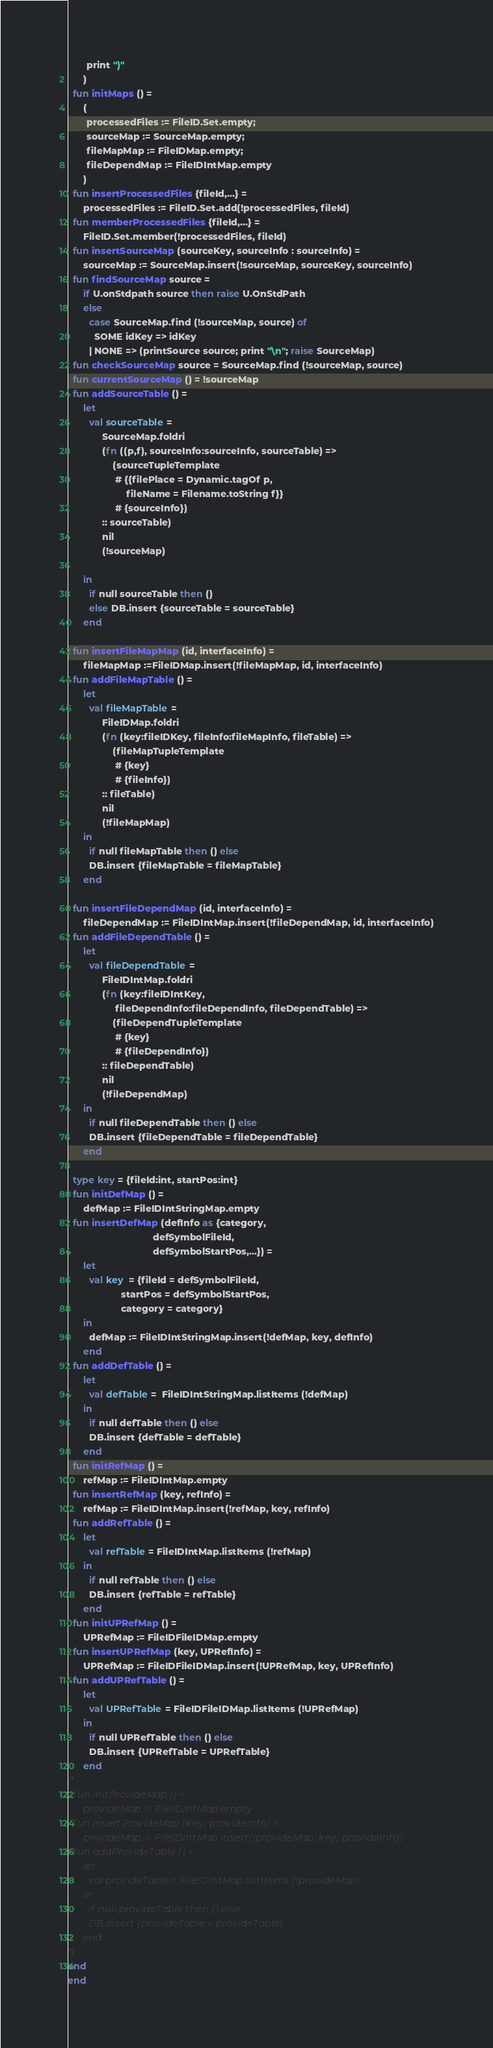Convert code to text. <code><loc_0><loc_0><loc_500><loc_500><_SML_>       print ")"
      )
  fun initMaps () = 
      (
       processedFiles := FileID.Set.empty;
       sourceMap := SourceMap.empty;
       fileMapMap := FileIDMap.empty;
       fileDependMap := FileIDIntMap.empty
      )
  fun insertProcessedFiles {fileId,...} = 
      processedFiles := FileID.Set.add(!processedFiles, fileId)
  fun memberProcessedFiles {fileId,...} = 
      FileID.Set.member(!processedFiles, fileId)
  fun insertSourceMap (sourceKey, sourceInfo : sourceInfo) =
      sourceMap := SourceMap.insert(!sourceMap, sourceKey, sourceInfo)
  fun findSourceMap source = 
      if U.onStdpath source then raise U.OnStdPath
      else
        case SourceMap.find (!sourceMap, source) of 
          SOME idKey => idKey
        | NONE => (printSource source; print "\n"; raise SourceMap)
  fun checkSourceMap source = SourceMap.find (!sourceMap, source)
  fun currentSourceMap () = !sourceMap
  fun addSourceTable () = 
      let
        val sourceTable = 
             SourceMap.foldri
             (fn ((p,f), sourceInfo:sourceInfo, sourceTable) =>
                 (sourceTupleTemplate
                  # {{filePlace = Dynamic.tagOf p, 
                      fileName = Filename.toString f}}
                  # {sourceInfo})
             :: sourceTable)
             nil
             (!sourceMap)

      in
        if null sourceTable then ()
        else DB.insert {sourceTable = sourceTable}
      end

  fun insertFileMapMap (id, interfaceInfo) = 
      fileMapMap :=FileIDMap.insert(!fileMapMap, id, interfaceInfo)
  fun addFileMapTable () =
      let
        val fileMapTable = 
             FileIDMap.foldri
             (fn (key:fileIDKey, fileInfo:fileMapInfo, fileTable) =>
                 (fileMapTupleTemplate
                  # {key}
                  # {fileInfo})
             :: fileTable)
             nil
             (!fileMapMap)
      in
        if null fileMapTable then () else 
        DB.insert {fileMapTable = fileMapTable}
      end

  fun insertFileDependMap (id, interfaceInfo) = 
      fileDependMap := FileIDIntMap.insert(!fileDependMap, id, interfaceInfo)
  fun addFileDependTable () =
      let
        val fileDependTable = 
             FileIDIntMap.foldri
             (fn (key:fileIDIntKey, 
                  fileDependInfo:fileDependInfo, fileDependTable) =>
                 (fileDependTupleTemplate
                  # {key}
                  # {fileDependInfo})
             :: fileDependTable)
             nil
             (!fileDependMap)
      in
        if null fileDependTable then () else 
        DB.insert {fileDependTable = fileDependTable}
      end

  type key = {fileId:int, startPos:int}
  fun initDefMap () =
      defMap := FileIDIntStringMap.empty
  fun insertDefMap (defInfo as {category, 
                                defSymbolFileId, 
                                defSymbolStartPos,...}) =
      let
        val key  = {fileId = defSymbolFileId,
                    startPos = defSymbolStartPos,
                    category = category}
      in
        defMap := FileIDIntStringMap.insert(!defMap, key, defInfo)
      end
  fun addDefTable () =
      let
        val defTable =  FileIDIntStringMap.listItems (!defMap)
      in
        if null defTable then () else 
        DB.insert {defTable = defTable}
      end
  fun initRefMap () =
      refMap := FileIDIntMap.empty
  fun insertRefMap (key, refInfo) =
      refMap := FileIDIntMap.insert(!refMap, key, refInfo)
  fun addRefTable () =
      let
        val refTable = FileIDIntMap.listItems (!refMap)
      in
        if null refTable then () else 
        DB.insert {refTable = refTable}
      end
  fun initUPRefMap () =
      UPRefMap := FileIDFileIDMap.empty
  fun insertUPRefMap (key, UPRefInfo) =
      UPRefMap := FileIDFileIDMap.insert(!UPRefMap, key, UPRefInfo)
  fun addUPRefTable () =
      let
        val UPRefTable = FileIDFileIDMap.listItems (!UPRefMap)
      in
        if null UPRefTable then () else 
        DB.insert {UPRefTable = UPRefTable}
      end
(*
  fun initProvideMap () =
      provideMap := FileIDIntMap.empty
  fun insertProvideMap (key, provideInfo) =
      provideMap := FileIDIntMap.insert(!provideMap, key, provideInfo)
  fun addProvideTable () =
      let
        val provideTable = FileIDIntMap.listItems (!provideMap)
      in
        if null provideTable then () else 
        DB.insert {provideTable = provideTable}
      end
*)      
end
end
</code> 